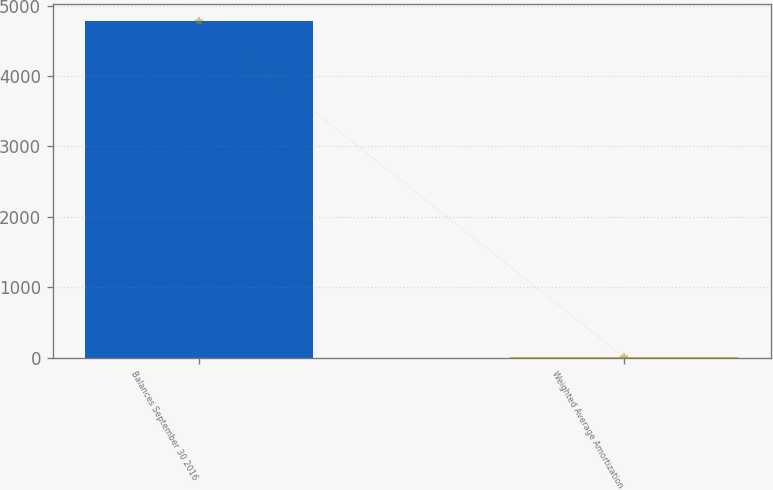<chart> <loc_0><loc_0><loc_500><loc_500><bar_chart><fcel>Balances September 30 2016<fcel>Weighted Average Amortization<nl><fcel>4786<fcel>5<nl></chart> 